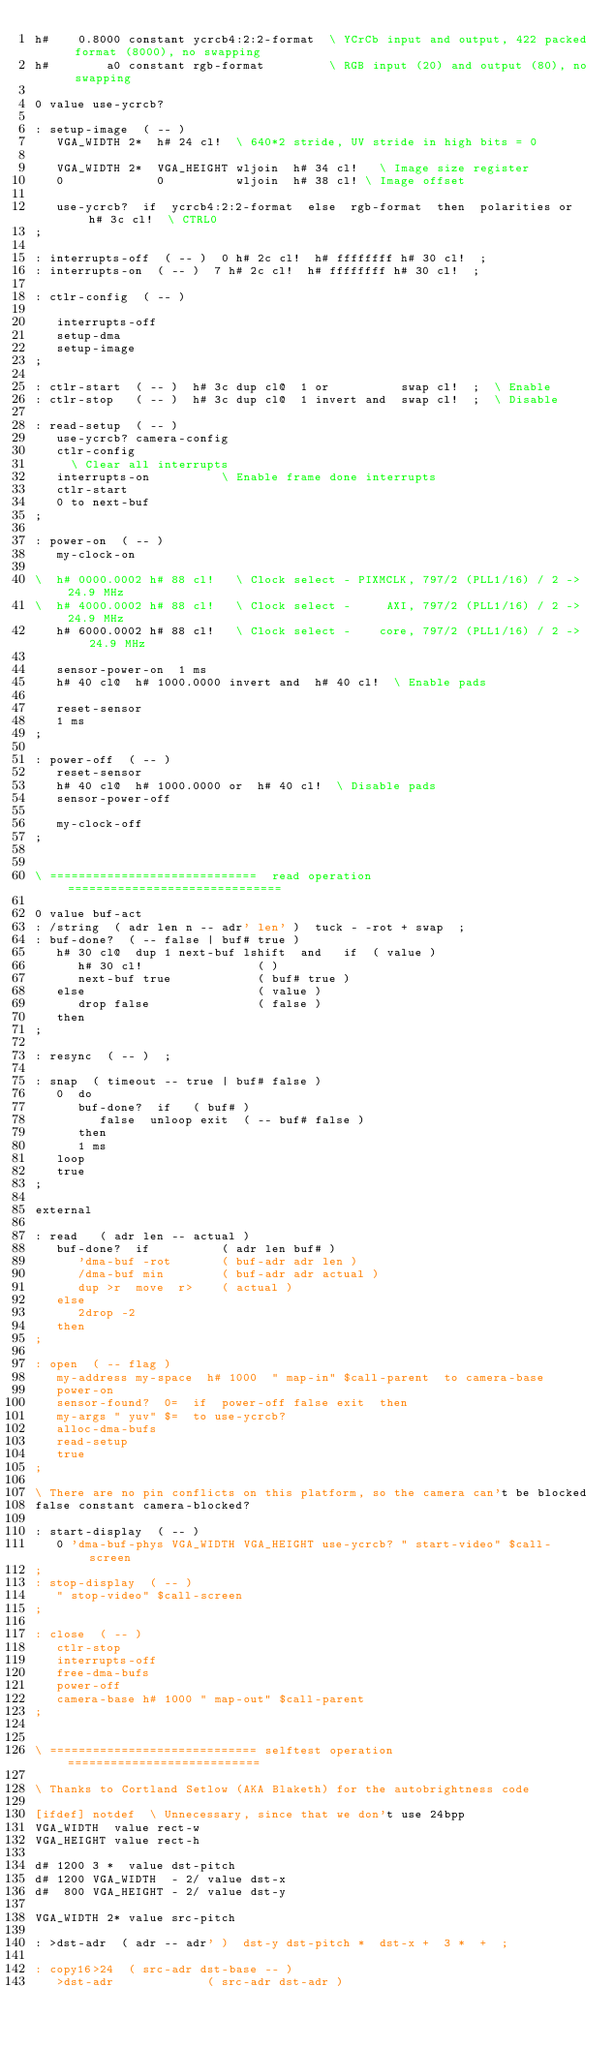<code> <loc_0><loc_0><loc_500><loc_500><_Forth_>h#    0.8000 constant ycrcb4:2:2-format  \ YCrCb input and output, 422 packed format (8000), no swapping
h#        a0 constant rgb-format         \ RGB input (20) and output (80), no swapping

0 value use-ycrcb?

: setup-image  ( -- )
   VGA_WIDTH 2*  h# 24 cl!	\ 640*2 stride, UV stride in high bits = 0

   VGA_WIDTH 2*  VGA_HEIGHT wljoin  h# 34 cl!   \ Image size register
   0             0          wljoin  h# 38 cl!	\ Image offset

   use-ycrcb?  if  ycrcb4:2:2-format  else  rgb-format  then  polarities or  h# 3c cl!  \ CTRL0
;

: interrupts-off  ( -- )  0 h# 2c cl!  h# ffffffff h# 30 cl!  ;
: interrupts-on  ( -- )  7 h# 2c cl!  h# ffffffff h# 30 cl!  ;

: ctlr-config  ( -- )

   interrupts-off
   setup-dma
   setup-image
;

: ctlr-start  ( -- )  h# 3c dup cl@  1 or          swap cl!  ;  \ Enable
: ctlr-stop   ( -- )  h# 3c dup cl@  1 invert and  swap cl!  ;	\ Disable

: read-setup  ( -- )
   use-ycrcb? camera-config
   ctlr-config
     \ Clear all interrupts
   interrupts-on          \ Enable frame done interrupts
   ctlr-start
   0 to next-buf
;

: power-on  ( -- )
   my-clock-on

\  h# 0000.0002 h# 88 cl!   \ Clock select - PIXMCLK, 797/2 (PLL1/16) / 2 -> 24.9 MHz
\  h# 4000.0002 h# 88 cl!   \ Clock select -     AXI, 797/2 (PLL1/16) / 2 -> 24.9 MHz
   h# 6000.0002 h# 88 cl!   \ Clock select -    core, 797/2 (PLL1/16) / 2 -> 24.9 MHz

   sensor-power-on  1 ms
   h# 40 cl@  h# 1000.0000 invert and  h# 40 cl!  \ Enable pads

   reset-sensor
   1 ms
;

: power-off  ( -- )
   reset-sensor
   h# 40 cl@  h# 1000.0000 or  h# 40 cl!  \ Disable pads
   sensor-power-off

   my-clock-off
;


\ =============================  read operation ==============================

0 value buf-act
: /string  ( adr len n -- adr' len' )  tuck - -rot + swap  ;
: buf-done?  ( -- false | buf# true )
   h# 30 cl@  dup 1 next-buf lshift  and   if  ( value )
      h# 30 cl!                ( )
      next-buf true            ( buf# true )
   else                        ( value )
      drop false               ( false )
   then
;

: resync  ( -- )  ;

: snap  ( timeout -- true | buf# false )
   0  do
      buf-done?  if   ( buf# )
         false  unloop exit  ( -- buf# false )
      then
      1 ms
   loop
   true
;

external

: read   ( adr len -- actual )
   buf-done?  if          ( adr len buf# )
      'dma-buf -rot       ( buf-adr adr len )
      /dma-buf min        ( buf-adr adr actual )
      dup >r  move  r>    ( actual )
   else
      2drop -2
   then
;

: open  ( -- flag )
   my-address my-space  h# 1000  " map-in" $call-parent  to camera-base
   power-on
   sensor-found?  0=  if  power-off false exit  then
   my-args " yuv" $=  to use-ycrcb?
   alloc-dma-bufs
   read-setup
   true
;

\ There are no pin conflicts on this platform, so the camera can't be blocked
false constant camera-blocked?

: start-display  ( -- )
   0 'dma-buf-phys VGA_WIDTH VGA_HEIGHT use-ycrcb? " start-video" $call-screen
;
: stop-display  ( -- )
   " stop-video" $call-screen
;

: close  ( -- )
   ctlr-stop
   interrupts-off
   free-dma-bufs
   power-off
   camera-base h# 1000 " map-out" $call-parent
;


\ ============================= selftest operation ===========================

\ Thanks to Cortland Setlow (AKA Blaketh) for the autobrightness code

[ifdef] notdef  \ Unnecessary, since that we don't use 24bpp
VGA_WIDTH  value rect-w
VGA_HEIGHT value rect-h

d# 1200 3 *  value dst-pitch
d# 1200 VGA_WIDTH  - 2/ value dst-x
d#  800 VGA_HEIGHT - 2/ value dst-y

VGA_WIDTH 2* value src-pitch

: >dst-adr  ( adr -- adr' )  dst-y dst-pitch *  dst-x +  3 *  +  ;

: copy16>24  ( src-adr dst-base -- )
   >dst-adr             ( src-adr dst-adr )</code> 